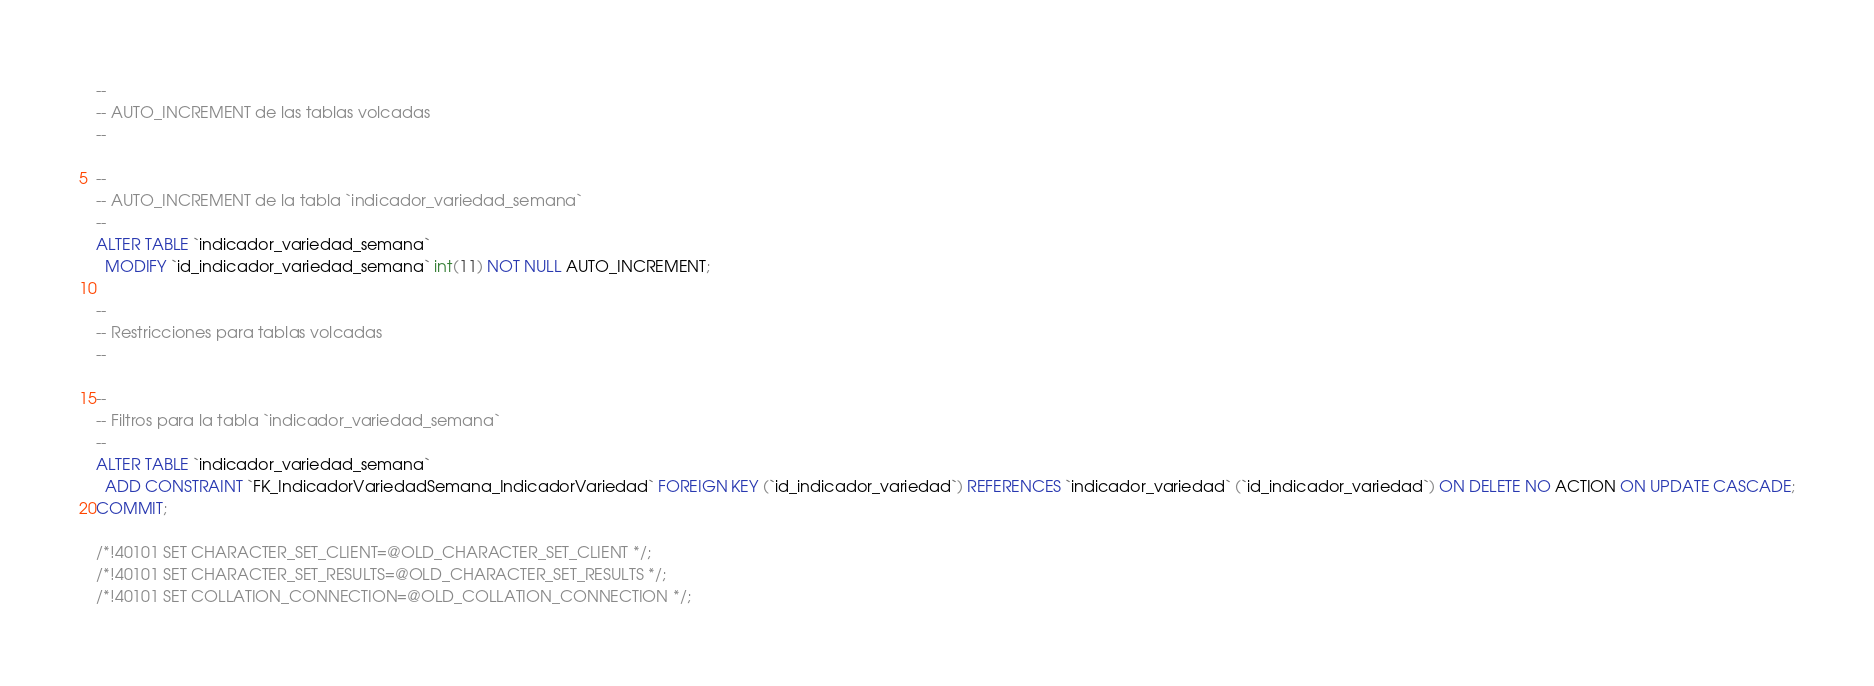Convert code to text. <code><loc_0><loc_0><loc_500><loc_500><_SQL_>--
-- AUTO_INCREMENT de las tablas volcadas
--

--
-- AUTO_INCREMENT de la tabla `indicador_variedad_semana`
--
ALTER TABLE `indicador_variedad_semana`
  MODIFY `id_indicador_variedad_semana` int(11) NOT NULL AUTO_INCREMENT;

--
-- Restricciones para tablas volcadas
--

--
-- Filtros para la tabla `indicador_variedad_semana`
--
ALTER TABLE `indicador_variedad_semana`
  ADD CONSTRAINT `FK_IndicadorVariedadSemana_IndicadorVariedad` FOREIGN KEY (`id_indicador_variedad`) REFERENCES `indicador_variedad` (`id_indicador_variedad`) ON DELETE NO ACTION ON UPDATE CASCADE;
COMMIT;

/*!40101 SET CHARACTER_SET_CLIENT=@OLD_CHARACTER_SET_CLIENT */;
/*!40101 SET CHARACTER_SET_RESULTS=@OLD_CHARACTER_SET_RESULTS */;
/*!40101 SET COLLATION_CONNECTION=@OLD_COLLATION_CONNECTION */;
</code> 